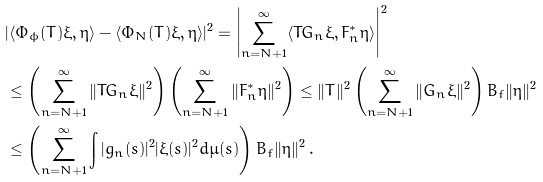<formula> <loc_0><loc_0><loc_500><loc_500>& | \langle \Phi _ { \phi } ( T ) \xi , \eta \rangle - \langle \Phi _ { N } ( T ) \xi , \eta \rangle | ^ { 2 } = \left | \sum _ { n = N + 1 } ^ { \infty } \langle T G _ { n } \xi , F _ { n } ^ { \ast } \eta \rangle \right | ^ { 2 } \\ & \leq \left ( \sum _ { n = N + 1 } ^ { \infty } \| T G _ { n } \xi \| ^ { 2 } \right ) \left ( \sum _ { n = N + 1 } ^ { \infty } \| F _ { n } ^ { \ast } \eta \| ^ { 2 } \right ) \leq \| T \| ^ { 2 } \left ( \sum _ { n = N + 1 } ^ { \infty } \| G _ { n } \xi \| ^ { 2 } \right ) B _ { f } \| \eta \| ^ { 2 } \\ & \leq \left ( \sum _ { n = N + 1 } ^ { \infty } \int | g _ { n } ( s ) | ^ { 2 } | \xi ( s ) | ^ { 2 } d \mu ( s ) \right ) B _ { f } \| \eta \| ^ { 2 } \, .</formula> 